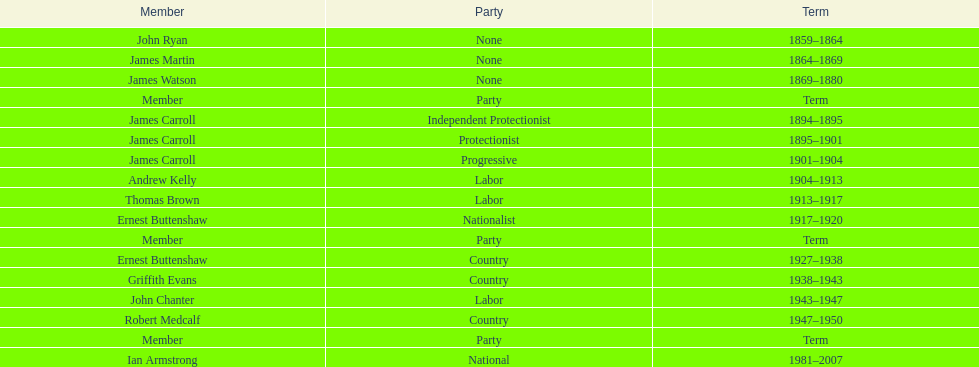What is the sum of service years of all members in the second incarnation? 26. 